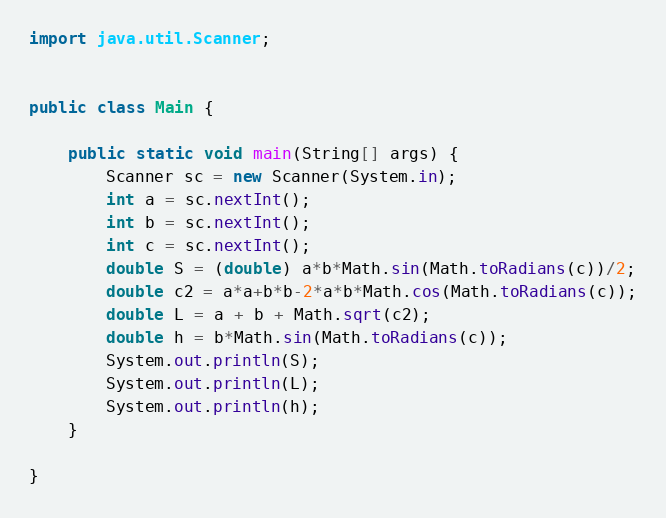Convert code to text. <code><loc_0><loc_0><loc_500><loc_500><_Java_>import java.util.Scanner;


public class Main {

	public static void main(String[] args) {
		Scanner sc = new Scanner(System.in);
		int a = sc.nextInt();
		int b = sc.nextInt();
		int c = sc.nextInt();
		double S = (double) a*b*Math.sin(Math.toRadians(c))/2;
		double c2 = a*a+b*b-2*a*b*Math.cos(Math.toRadians(c));
		double L = a + b + Math.sqrt(c2);
		double h = b*Math.sin(Math.toRadians(c));
		System.out.println(S);
		System.out.println(L);
		System.out.println(h);
	}

}</code> 